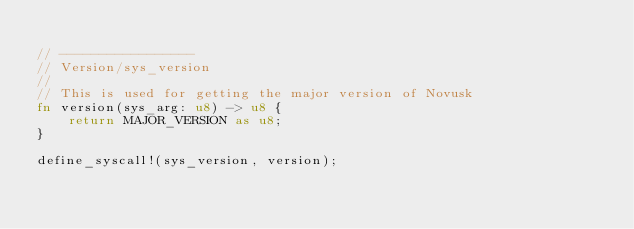Convert code to text. <code><loc_0><loc_0><loc_500><loc_500><_Rust_>
// -----------------
// Version/sys_version
//
// This is used for getting the major version of Novusk
fn version(sys_arg: u8) -> u8 {
    return MAJOR_VERSION as u8;
}

define_syscall!(sys_version, version);
</code> 